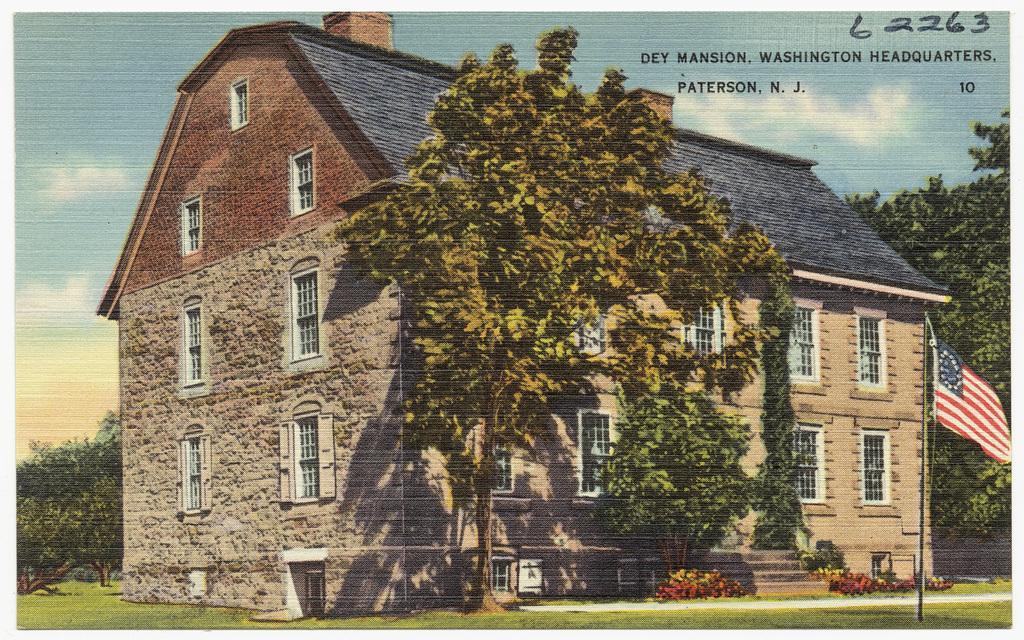Please provide a concise description of this image. It is a portrait of a building and inside that building there are many trees and on the right side there is a flag. 